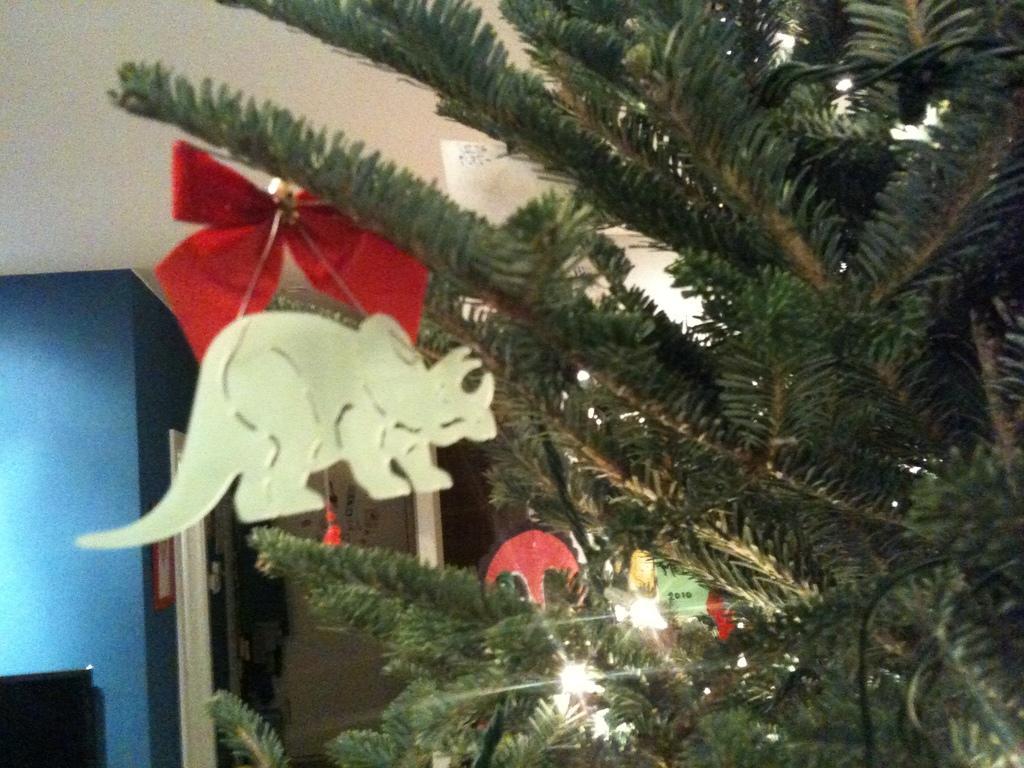Please provide a concise description of this image. In this image there is a Christmas tree. There is a toy and few decorative items and lights are hanging on the Christmas tree. Background there is a wall having a door. Left bottom there is an object. 